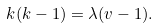Convert formula to latex. <formula><loc_0><loc_0><loc_500><loc_500>k ( k - 1 ) = \lambda ( v - 1 ) .</formula> 